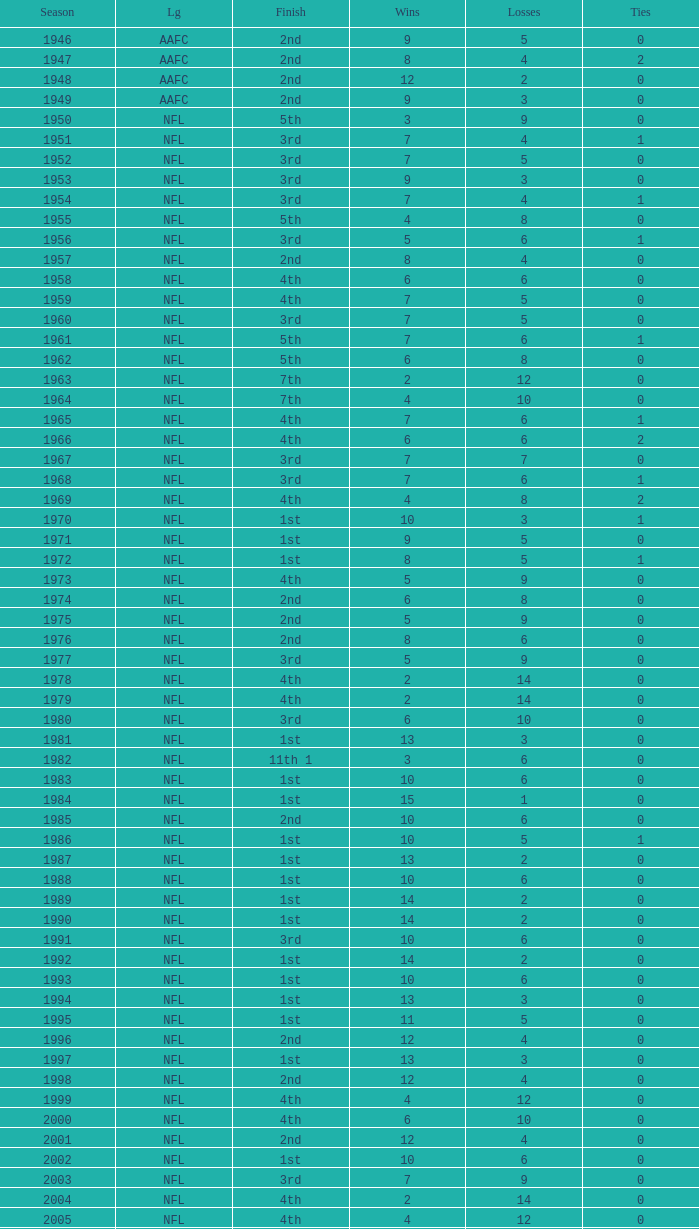What league had a finish of 2nd and 3 losses? AAFC. Can you parse all the data within this table? {'header': ['Season', 'Lg', 'Finish', 'Wins', 'Losses', 'Ties'], 'rows': [['1946', 'AAFC', '2nd', '9', '5', '0'], ['1947', 'AAFC', '2nd', '8', '4', '2'], ['1948', 'AAFC', '2nd', '12', '2', '0'], ['1949', 'AAFC', '2nd', '9', '3', '0'], ['1950', 'NFL', '5th', '3', '9', '0'], ['1951', 'NFL', '3rd', '7', '4', '1'], ['1952', 'NFL', '3rd', '7', '5', '0'], ['1953', 'NFL', '3rd', '9', '3', '0'], ['1954', 'NFL', '3rd', '7', '4', '1'], ['1955', 'NFL', '5th', '4', '8', '0'], ['1956', 'NFL', '3rd', '5', '6', '1'], ['1957', 'NFL', '2nd', '8', '4', '0'], ['1958', 'NFL', '4th', '6', '6', '0'], ['1959', 'NFL', '4th', '7', '5', '0'], ['1960', 'NFL', '3rd', '7', '5', '0'], ['1961', 'NFL', '5th', '7', '6', '1'], ['1962', 'NFL', '5th', '6', '8', '0'], ['1963', 'NFL', '7th', '2', '12', '0'], ['1964', 'NFL', '7th', '4', '10', '0'], ['1965', 'NFL', '4th', '7', '6', '1'], ['1966', 'NFL', '4th', '6', '6', '2'], ['1967', 'NFL', '3rd', '7', '7', '0'], ['1968', 'NFL', '3rd', '7', '6', '1'], ['1969', 'NFL', '4th', '4', '8', '2'], ['1970', 'NFL', '1st', '10', '3', '1'], ['1971', 'NFL', '1st', '9', '5', '0'], ['1972', 'NFL', '1st', '8', '5', '1'], ['1973', 'NFL', '4th', '5', '9', '0'], ['1974', 'NFL', '2nd', '6', '8', '0'], ['1975', 'NFL', '2nd', '5', '9', '0'], ['1976', 'NFL', '2nd', '8', '6', '0'], ['1977', 'NFL', '3rd', '5', '9', '0'], ['1978', 'NFL', '4th', '2', '14', '0'], ['1979', 'NFL', '4th', '2', '14', '0'], ['1980', 'NFL', '3rd', '6', '10', '0'], ['1981', 'NFL', '1st', '13', '3', '0'], ['1982', 'NFL', '11th 1', '3', '6', '0'], ['1983', 'NFL', '1st', '10', '6', '0'], ['1984', 'NFL', '1st', '15', '1', '0'], ['1985', 'NFL', '2nd', '10', '6', '0'], ['1986', 'NFL', '1st', '10', '5', '1'], ['1987', 'NFL', '1st', '13', '2', '0'], ['1988', 'NFL', '1st', '10', '6', '0'], ['1989', 'NFL', '1st', '14', '2', '0'], ['1990', 'NFL', '1st', '14', '2', '0'], ['1991', 'NFL', '3rd', '10', '6', '0'], ['1992', 'NFL', '1st', '14', '2', '0'], ['1993', 'NFL', '1st', '10', '6', '0'], ['1994', 'NFL', '1st', '13', '3', '0'], ['1995', 'NFL', '1st', '11', '5', '0'], ['1996', 'NFL', '2nd', '12', '4', '0'], ['1997', 'NFL', '1st', '13', '3', '0'], ['1998', 'NFL', '2nd', '12', '4', '0'], ['1999', 'NFL', '4th', '4', '12', '0'], ['2000', 'NFL', '4th', '6', '10', '0'], ['2001', 'NFL', '2nd', '12', '4', '0'], ['2002', 'NFL', '1st', '10', '6', '0'], ['2003', 'NFL', '3rd', '7', '9', '0'], ['2004', 'NFL', '4th', '2', '14', '0'], ['2005', 'NFL', '4th', '4', '12', '0'], ['2006', 'NFL', '3rd', '7', '9', '0'], ['2007', 'NFL', '3rd', '5', '11', '0'], ['2008', 'NFL', '2nd', '7', '9', '0'], ['2009', 'NFL', '2nd', '8', '8', '0'], ['2010', 'NFL', '3rd', '6', '10', '0'], ['2011', 'NFL', '1st', '13', '3', '0'], ['2012', 'NFL', '1st', '11', '4', '1'], ['2013', 'NFL', '2nd', '6', '2', '0']]} 